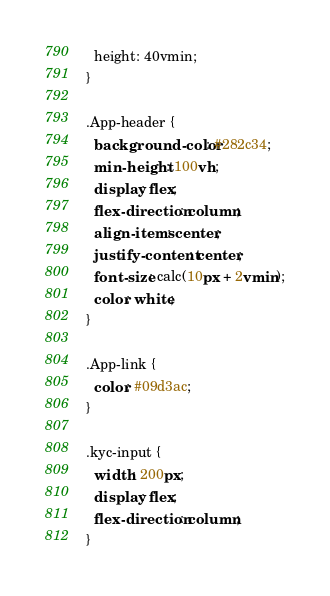<code> <loc_0><loc_0><loc_500><loc_500><_CSS_>  height: 40vmin;
}

.App-header {
  background-color: #282c34;
  min-height: 100vh;
  display: flex;
  flex-direction: column;
  align-items: center;
  justify-content: center;
  font-size: calc(10px + 2vmin);
  color: white;
}

.App-link {
  color: #09d3ac;
}

.kyc-input {
  width: 200px;
  display: flex;
  flex-direction: column;
}</code> 